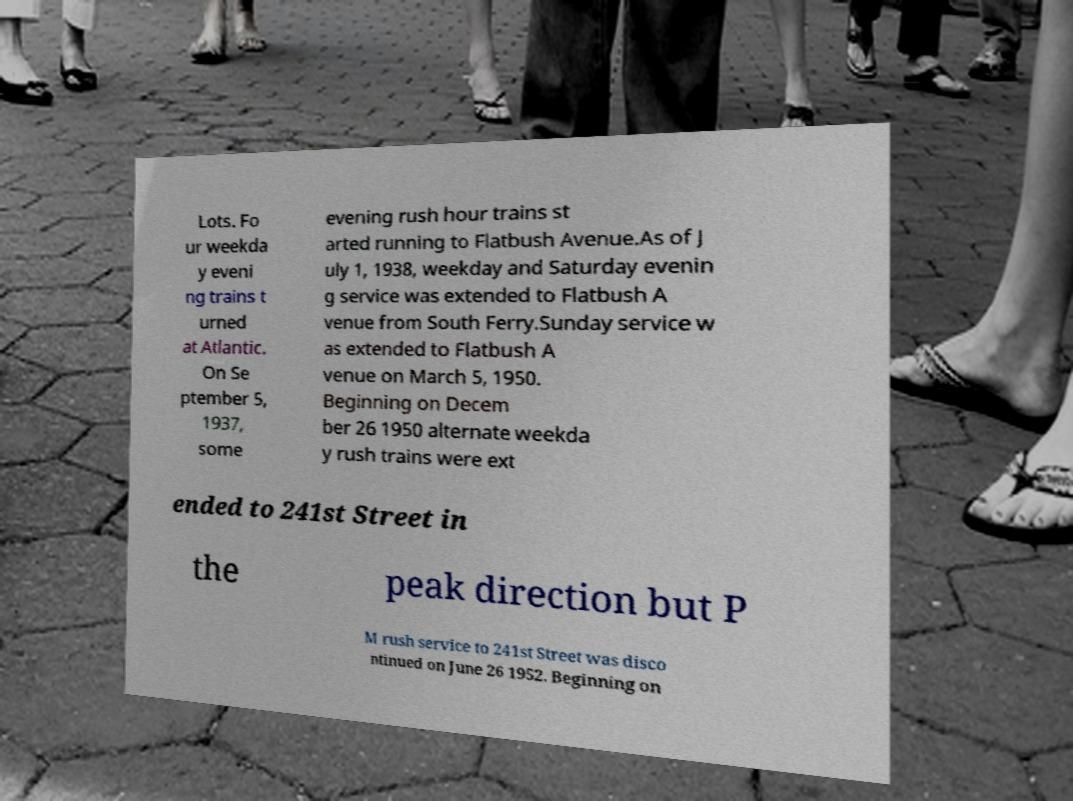Please read and relay the text visible in this image. What does it say? Lots. Fo ur weekda y eveni ng trains t urned at Atlantic. On Se ptember 5, 1937, some evening rush hour trains st arted running to Flatbush Avenue.As of J uly 1, 1938, weekday and Saturday evenin g service was extended to Flatbush A venue from South Ferry.Sunday service w as extended to Flatbush A venue on March 5, 1950. Beginning on Decem ber 26 1950 alternate weekda y rush trains were ext ended to 241st Street in the peak direction but P M rush service to 241st Street was disco ntinued on June 26 1952. Beginning on 